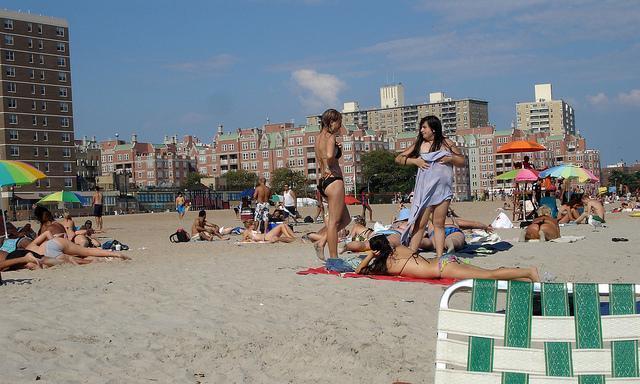How many people can you see?
Give a very brief answer. 4. How many motorcycles do you see?
Give a very brief answer. 0. 